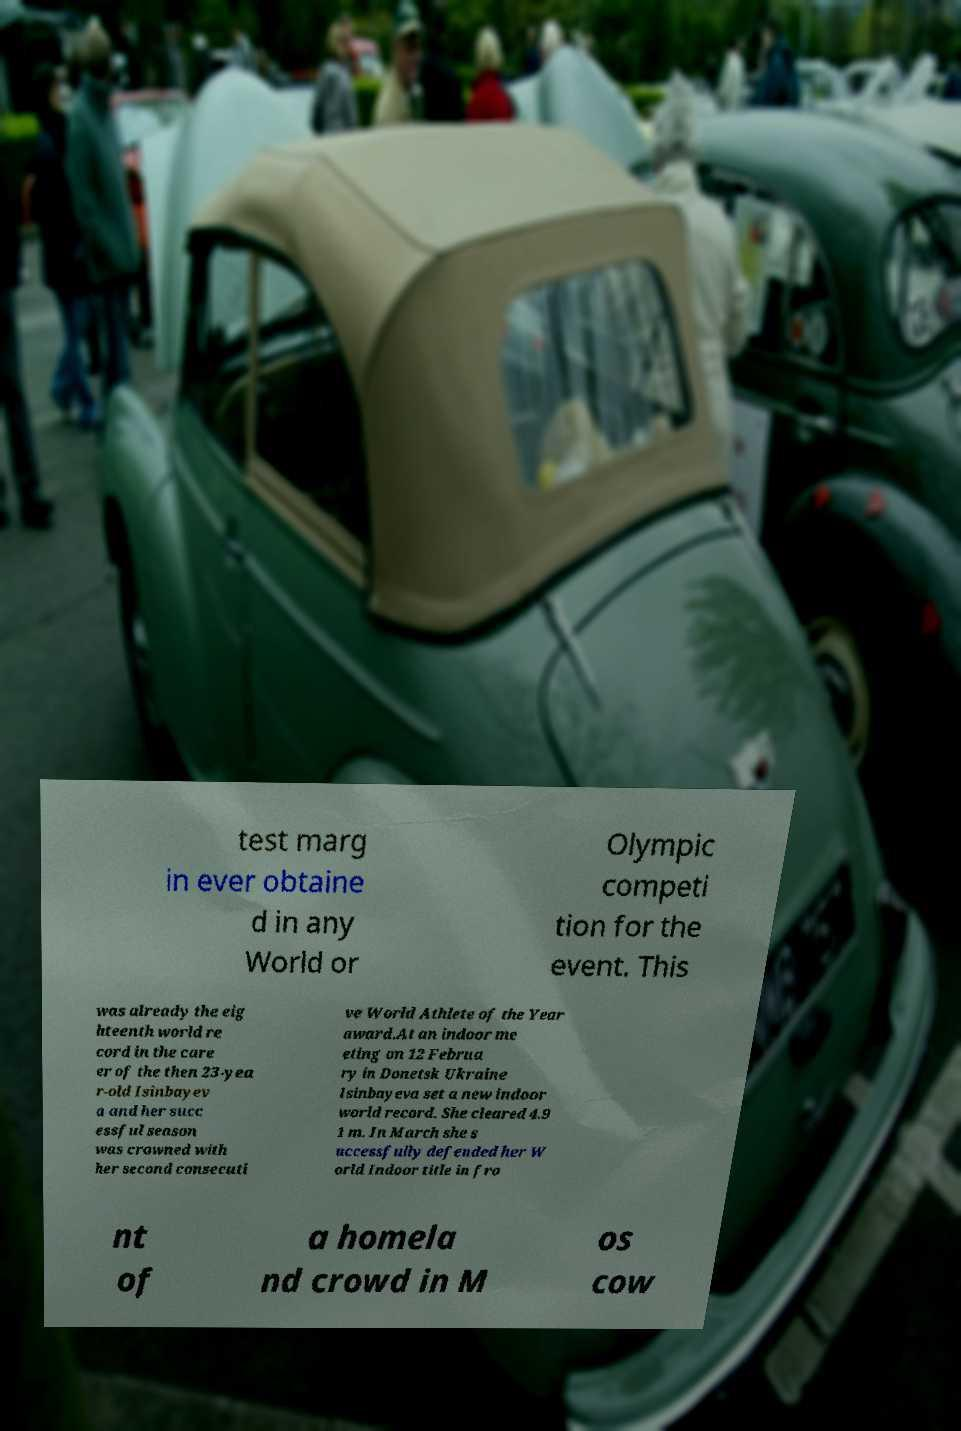There's text embedded in this image that I need extracted. Can you transcribe it verbatim? test marg in ever obtaine d in any World or Olympic competi tion for the event. This was already the eig hteenth world re cord in the care er of the then 23-yea r-old Isinbayev a and her succ essful season was crowned with her second consecuti ve World Athlete of the Year award.At an indoor me eting on 12 Februa ry in Donetsk Ukraine Isinbayeva set a new indoor world record. She cleared 4.9 1 m. In March she s uccessfully defended her W orld Indoor title in fro nt of a homela nd crowd in M os cow 